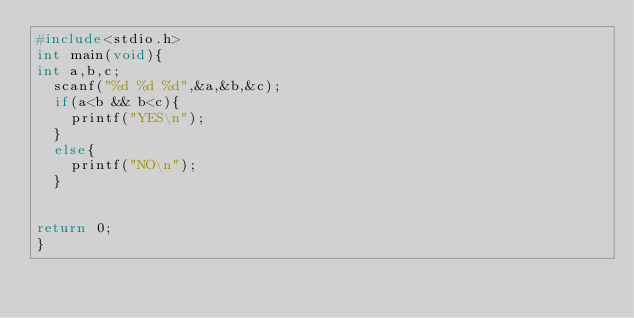<code> <loc_0><loc_0><loc_500><loc_500><_C_>#include<stdio.h>
int main(void){
int a,b,c;
	scanf("%d %d %d",&a,&b,&c);
	if(a<b && b<c){
		printf("YES\n");
	}
	else{
		printf("NO\n");
	}
	

return 0;
}</code> 